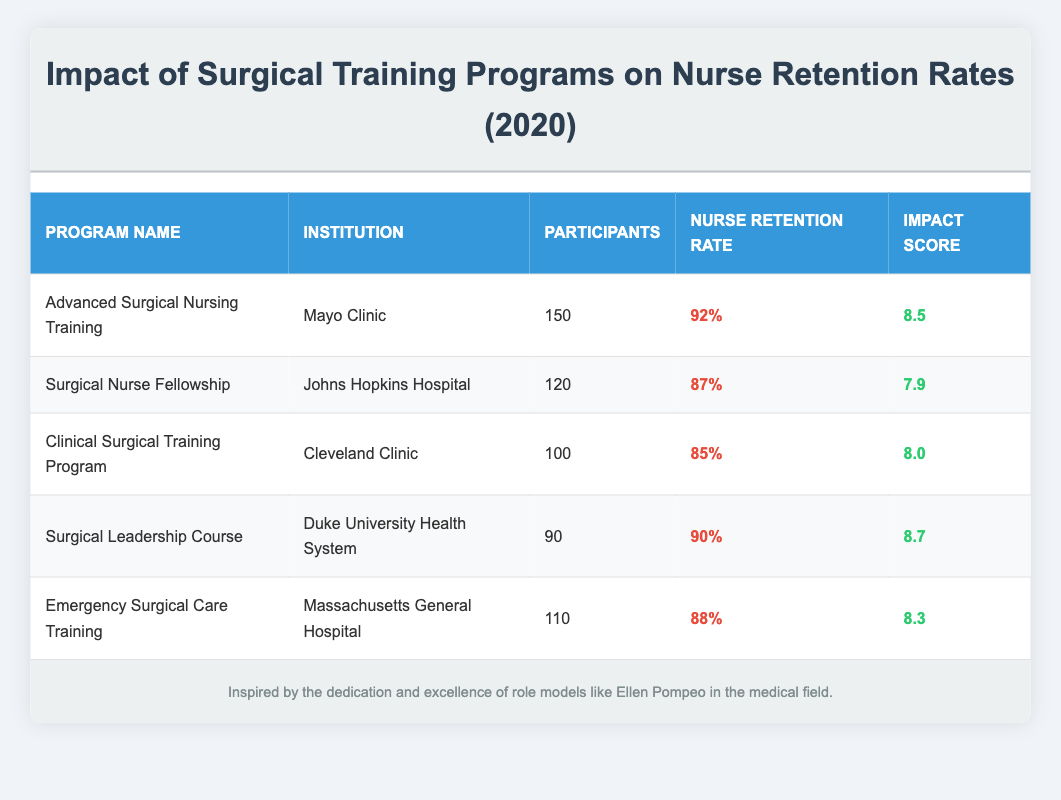What is the highest nurse retention rate among the programs listed? The table shows various nurse retention rates for different programs. The highest value is listed for the "Advanced Surgical Nursing Training" at 92%.
Answer: 92% Which institution offers the "Surgical Leadership Course"? The table indicates that the "Surgical Leadership Course" is offered by Duke University Health System.
Answer: Duke University Health System How many participants were involved in the "Surgical Nurse Fellowship" program? The table specifies that the "Surgical Nurse Fellowship" program had a total of 120 participants.
Answer: 120 What is the average impact score of all the programs? To find the average impact score, add all the impact scores: (8.5 + 7.9 + 8.0 + 8.7 + 8.3) = 41.4. There are 5 programs, so divide 41.4 by 5, which equals 8.28.
Answer: 8.28 Is the impact score of the "Emergency Surgical Care Training" higher than 8.0? The table lists the impact score for the "Emergency Surgical Care Training" as 8.3, which is indeed higher than 8.0, making this statement true.
Answer: Yes What is the total number of participants across all programs? To find the total number of participants, sum the participants from each program: 150 + 120 + 100 + 90 + 110 = 570.
Answer: 570 Does the "Clinical Surgical Training Program" have the lowest nurse retention rate? The "Clinical Surgical Training Program" has a retention rate of 85%. The lowest rate is that of the "Surgical Nurse Fellowship" at 87%, therefore this statement is false.
Answer: No Which program has an impact score of 8.3? The program with an impact score of 8.3 is the "Emergency Surgical Care Training."
Answer: Emergency Surgical Care Training If we consider only the top three programs by nurse retention rate, what is their average retention rate? The top three programs by retention rate are "Advanced Surgical Nursing Training" (92%), "Surgical Leadership Course" (90%), and "Emergency Surgical Care Training" (88%). Their average retention rate is (92 + 90 + 88) / 3 = 90.
Answer: 90 